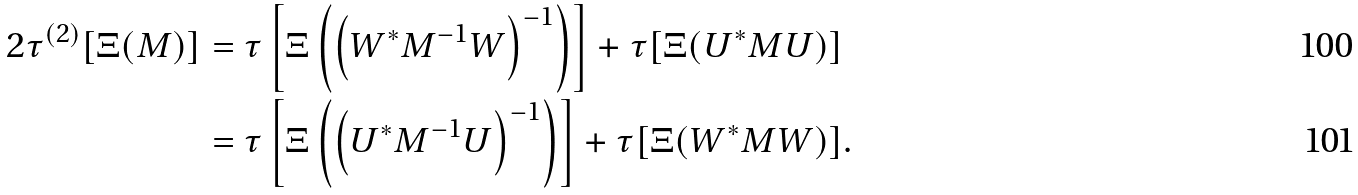<formula> <loc_0><loc_0><loc_500><loc_500>2 \tau ^ { ( 2 ) } [ \Xi ( { M } ) ] & = \tau \left [ \Xi \left ( \left ( W ^ { * } { M ^ { - 1 } } W \right ) ^ { - 1 } \right ) \right ] + \tau [ \Xi ( U ^ { * } { M } U ) ] \\ & = \tau \left [ \Xi \left ( \left ( U ^ { * } { M ^ { - 1 } } U \right ) ^ { - 1 } \right ) \right ] + \tau [ \Xi ( W ^ { * } { M } W ) ] .</formula> 